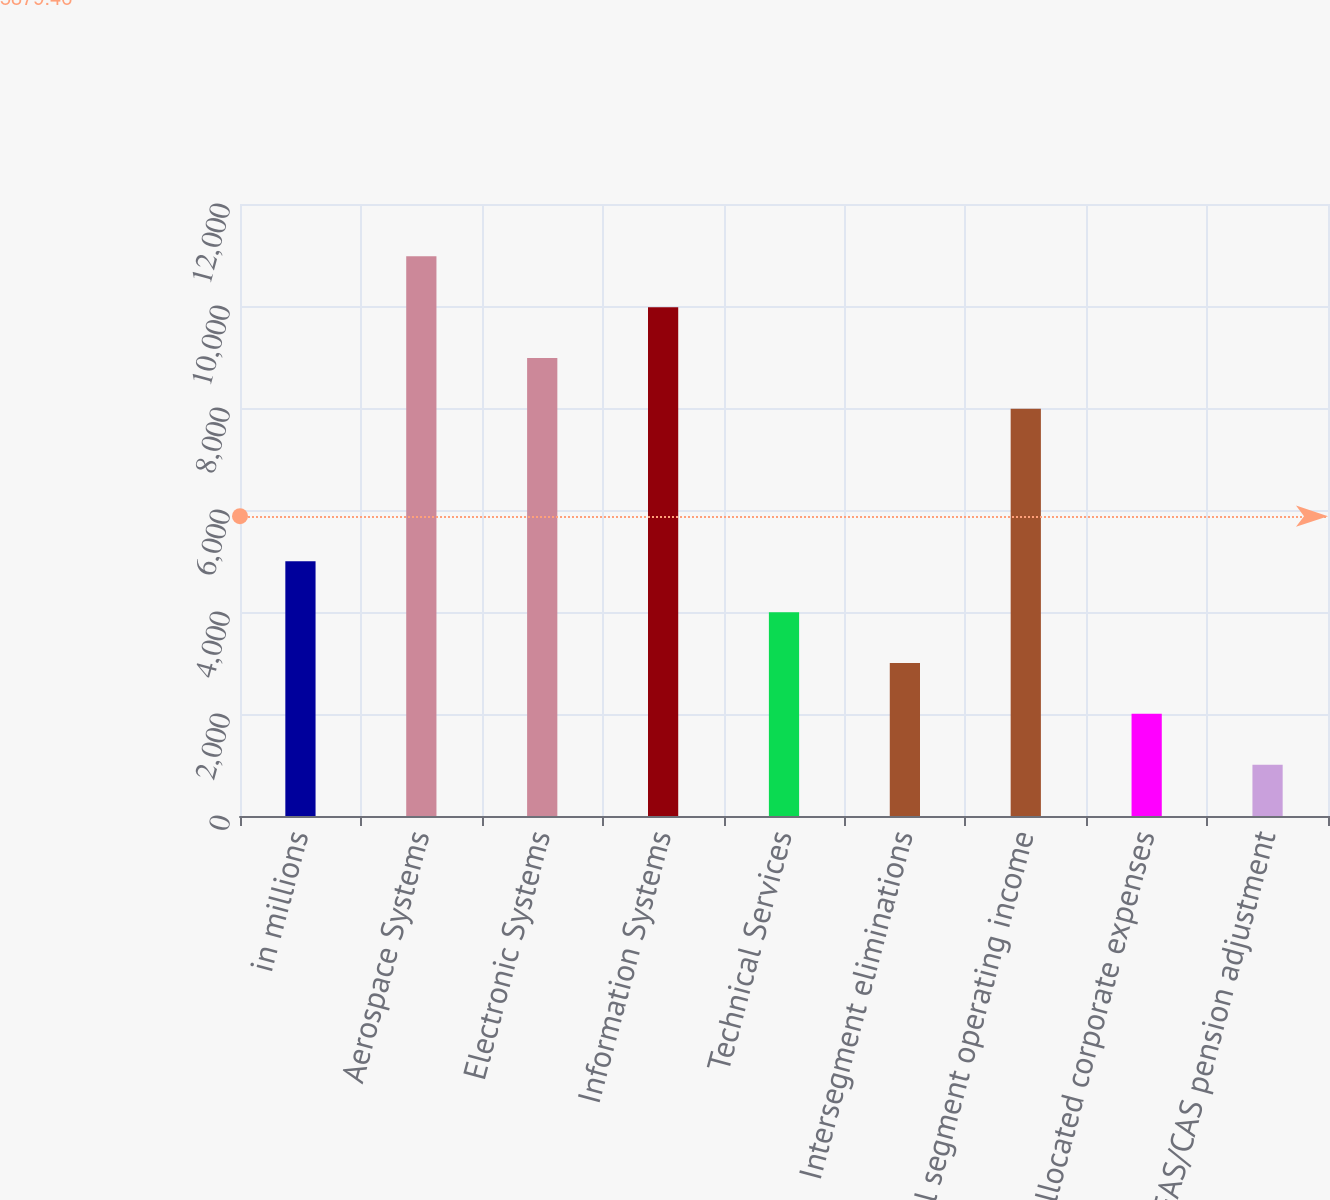<chart> <loc_0><loc_0><loc_500><loc_500><bar_chart><fcel>in millions<fcel>Aerospace Systems<fcel>Electronic Systems<fcel>Information Systems<fcel>Technical Services<fcel>Intersegment eliminations<fcel>Total segment operating income<fcel>Unallocated corporate expenses<fcel>Net FAS/CAS pension adjustment<nl><fcel>4993.5<fcel>10973.7<fcel>8980.3<fcel>9977<fcel>3996.8<fcel>3000.1<fcel>7983.6<fcel>2003.4<fcel>1006.7<nl></chart> 